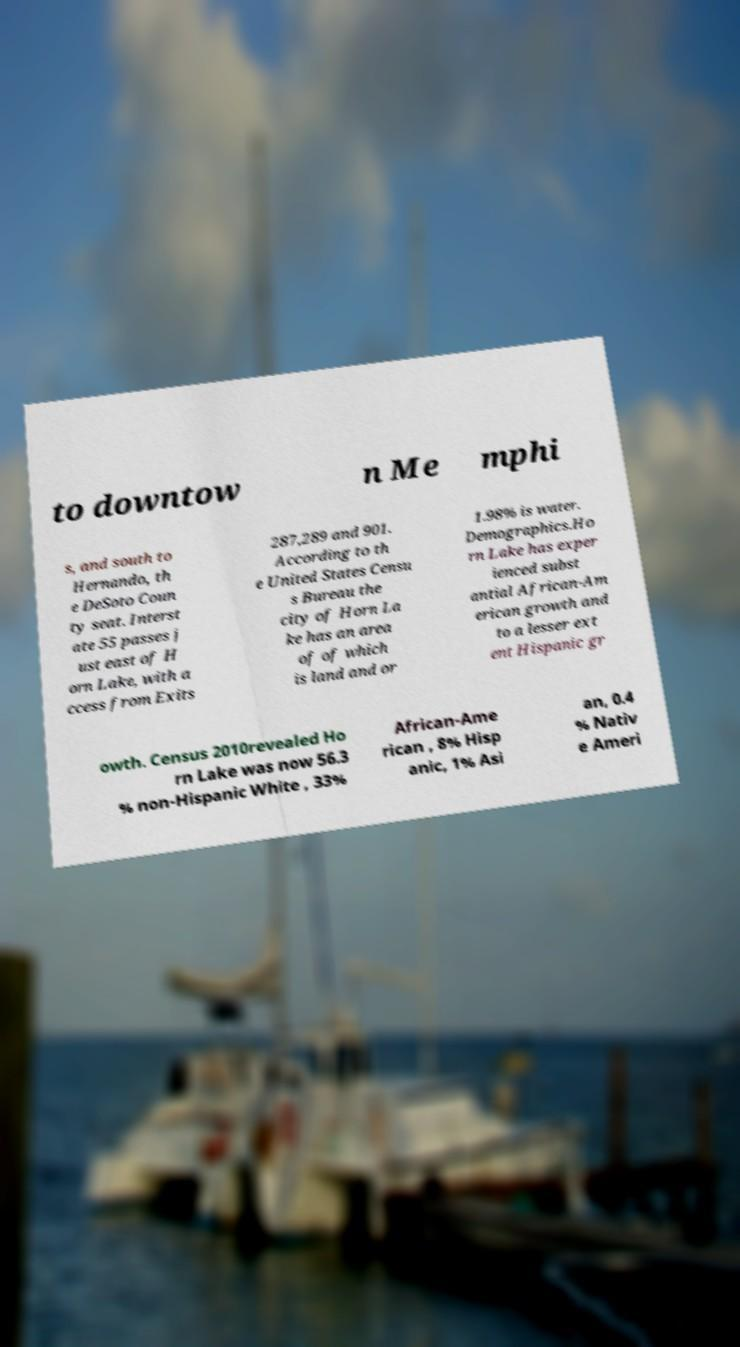Can you accurately transcribe the text from the provided image for me? to downtow n Me mphi s, and south to Hernando, th e DeSoto Coun ty seat. Interst ate 55 passes j ust east of H orn Lake, with a ccess from Exits 287,289 and 901. According to th e United States Censu s Bureau the city of Horn La ke has an area of of which is land and or 1.98% is water. Demographics.Ho rn Lake has exper ienced subst antial African-Am erican growth and to a lesser ext ent Hispanic gr owth. Census 2010revealed Ho rn Lake was now 56.3 % non-Hispanic White , 33% African-Ame rican , 8% Hisp anic, 1% Asi an, 0.4 % Nativ e Ameri 